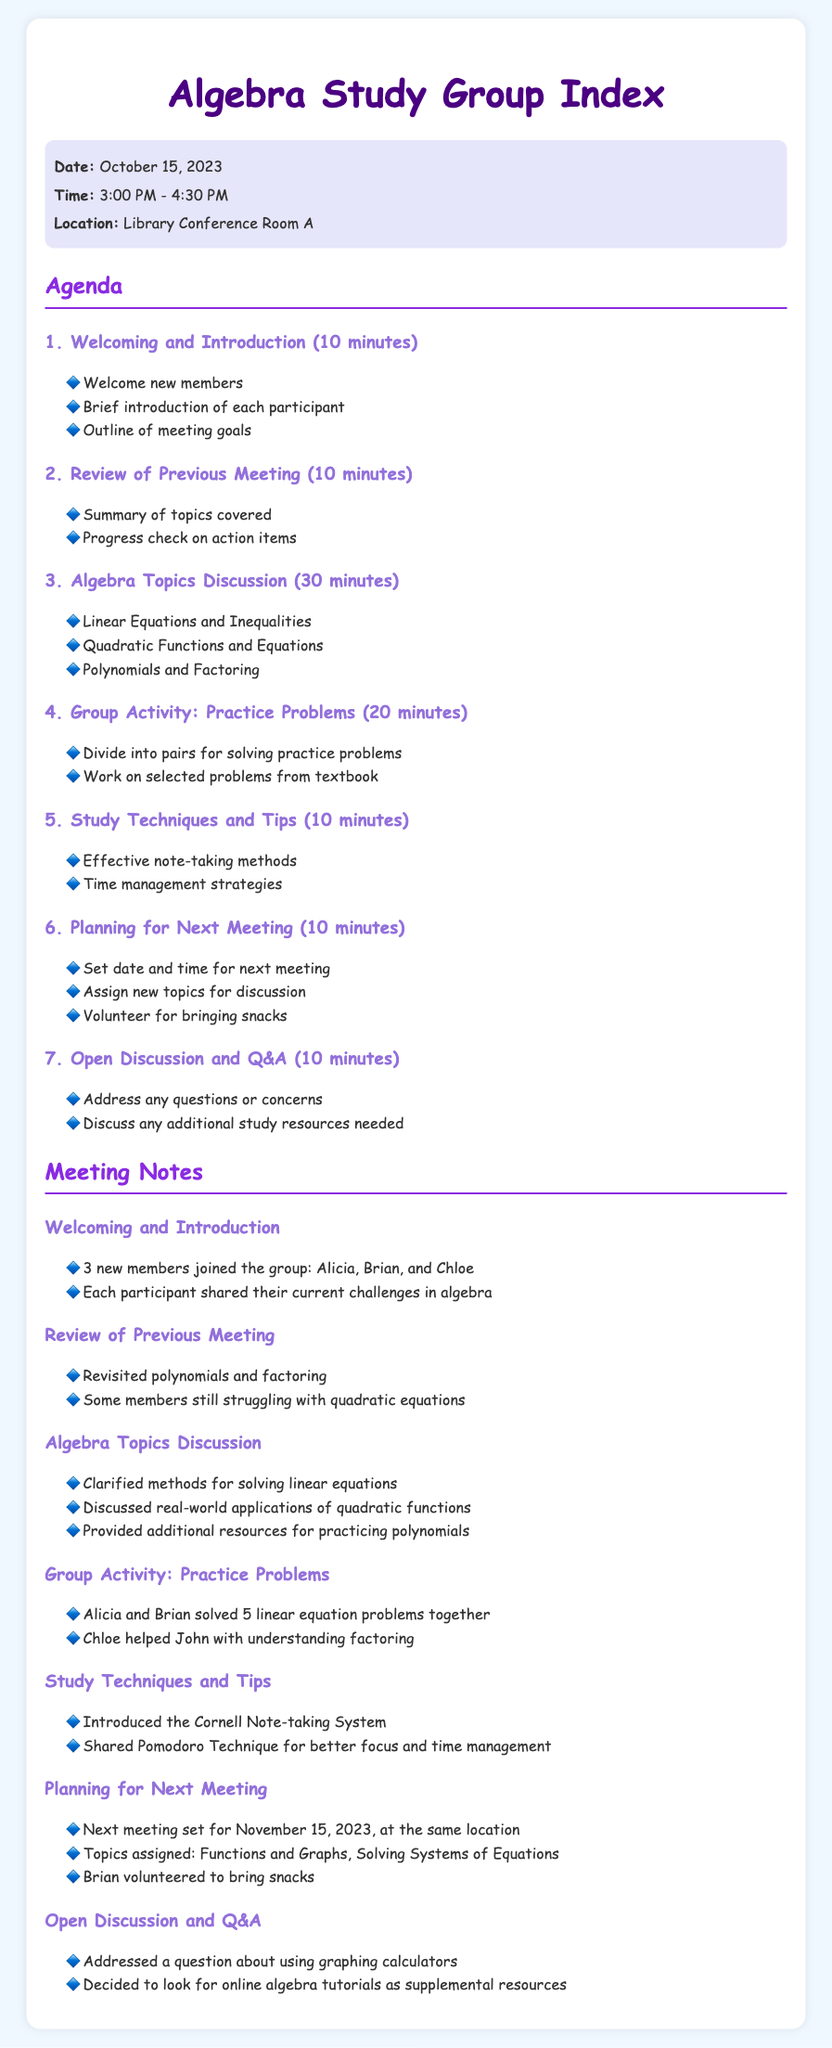What is the date of the meeting? The date of the meeting is explicitly stated in the meeting-info section under the date header.
Answer: October 15, 2023 Where is the study group meeting held? The location of the meeting is provided in the meeting-info section under the location header.
Answer: Library Conference Room A How long is the discussion on Algebra Topics? The duration of this agenda item is indicated in the agenda section where each item lists its time allocation.
Answer: 30 minutes What new technique was introduced for note-taking? The study techniques discussed include a specific method mentioned during the study techniques and tips agenda item.
Answer: Cornell Note-taking System Who volunteered to bring snacks for the next meeting? The volunteer for snacks is mentioned in the planning for the next meeting notes section.
Answer: Brian How many new members joined the group? The number of new members is described in the welcoming and introduction notes.
Answer: 3 What topics are assigned for the next meeting? The assigned topics for discussion at the next meeting are listed in the planning for the next meeting notes section.
Answer: Functions and Graphs, Solving Systems of Equations What was addressed during the Open Discussion and Q&A? The issues discussed are listed in the open discussion and Q&A notes, which includes topics or concerns raised.
Answer: Using graphing calculators How many members shared their current challenges in algebra? This information is captured in the welcoming and introduction notes, indicating participation during the meeting.
Answer: Each participant 